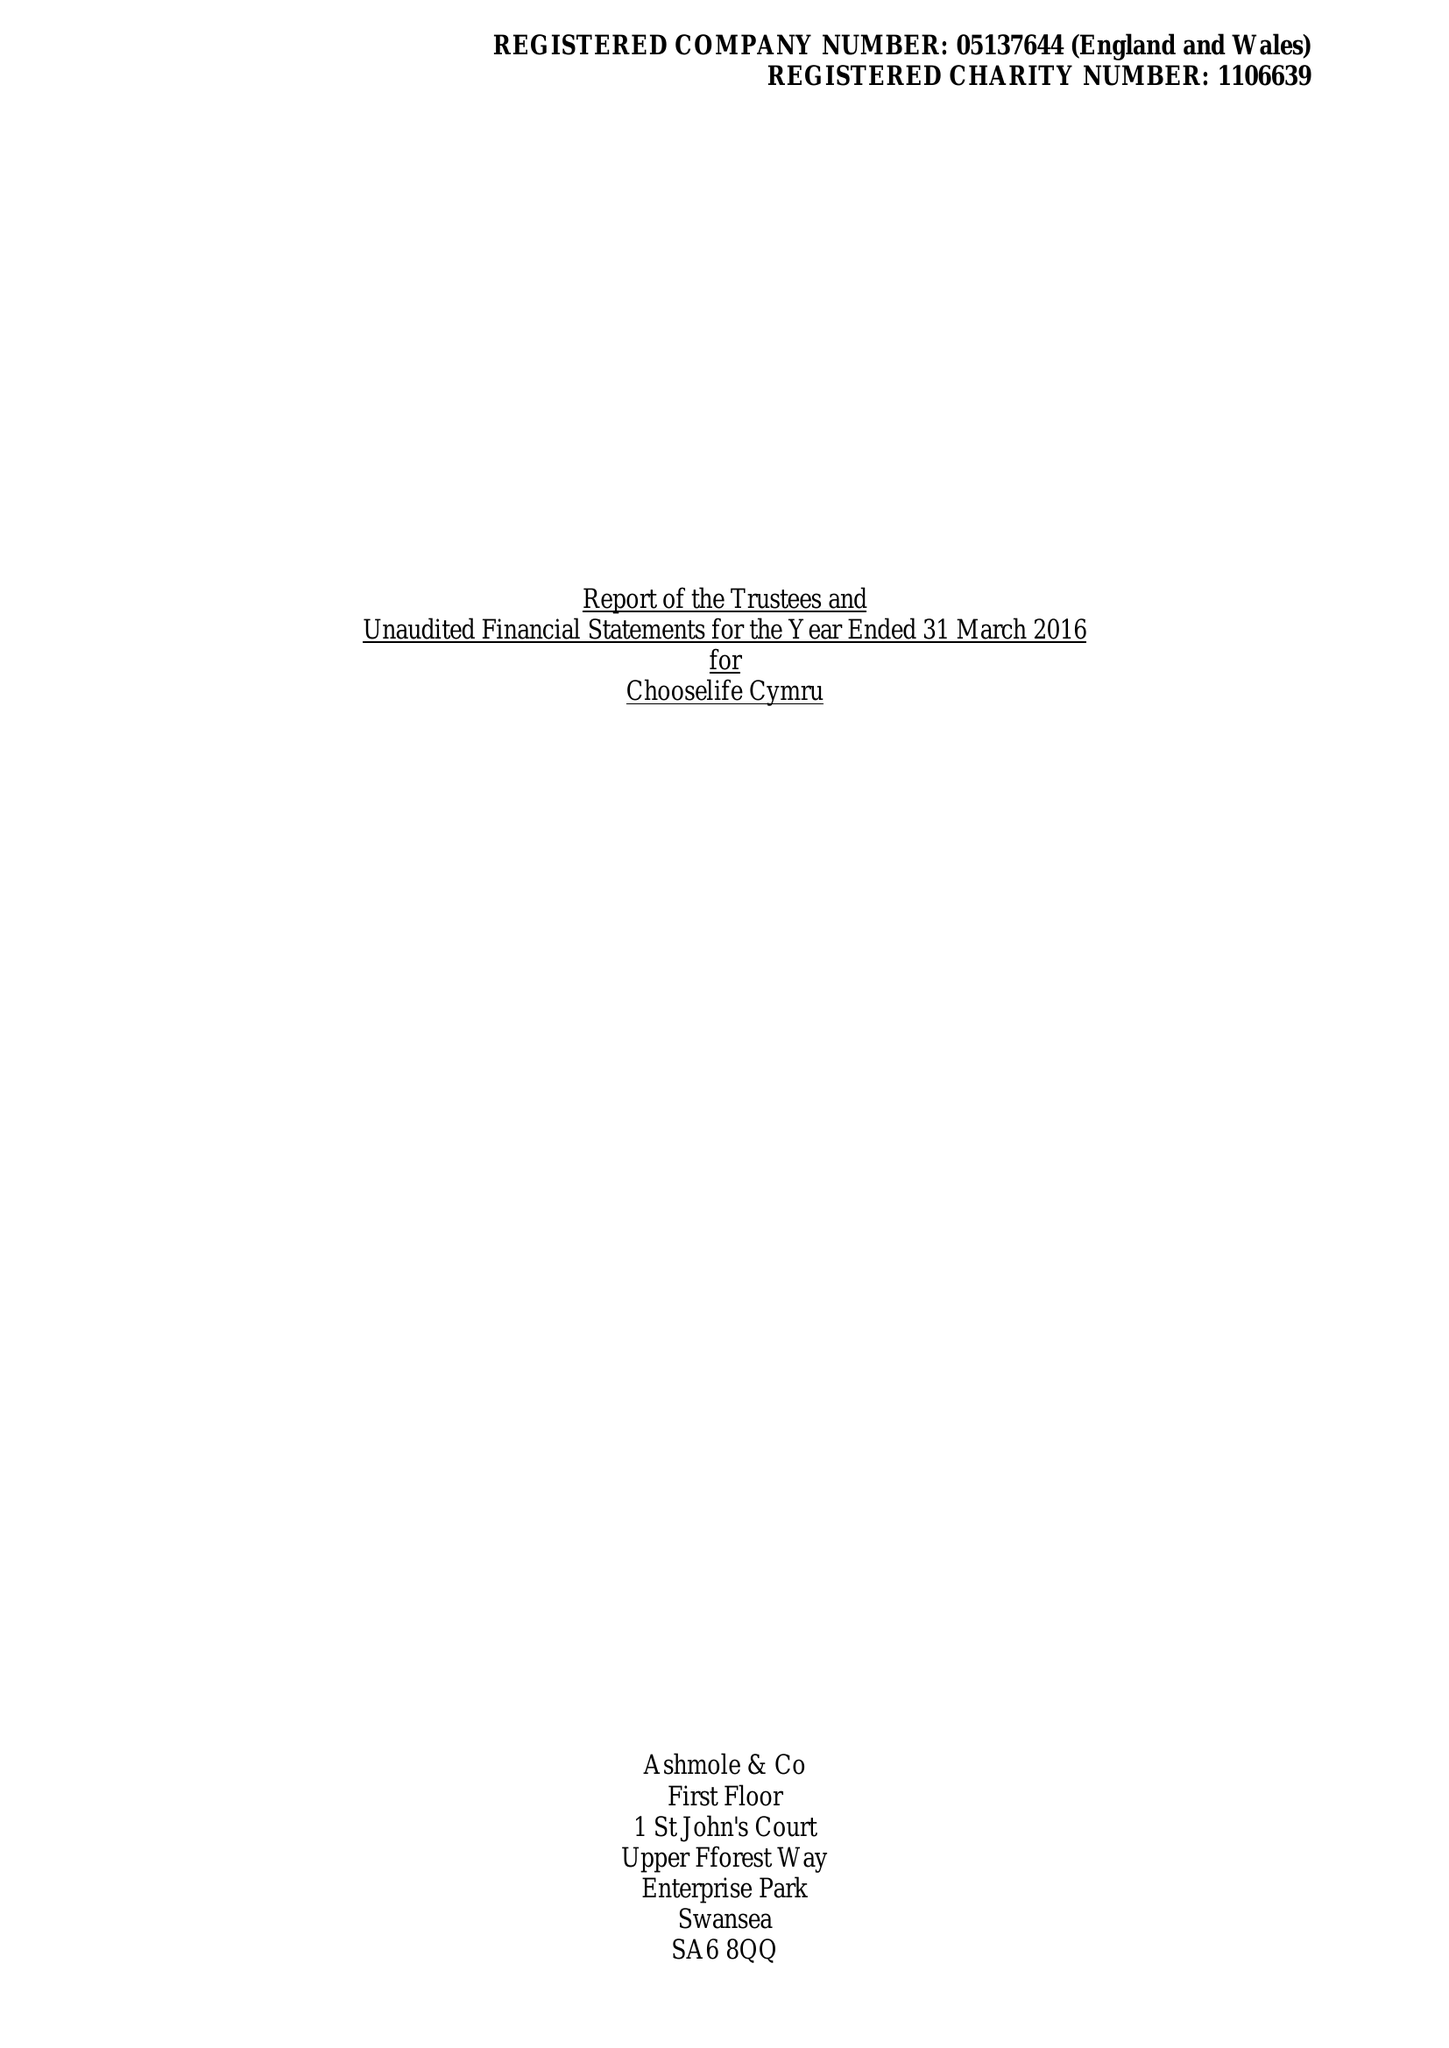What is the value for the address__post_town?
Answer the question using a single word or phrase. LLANELLI 